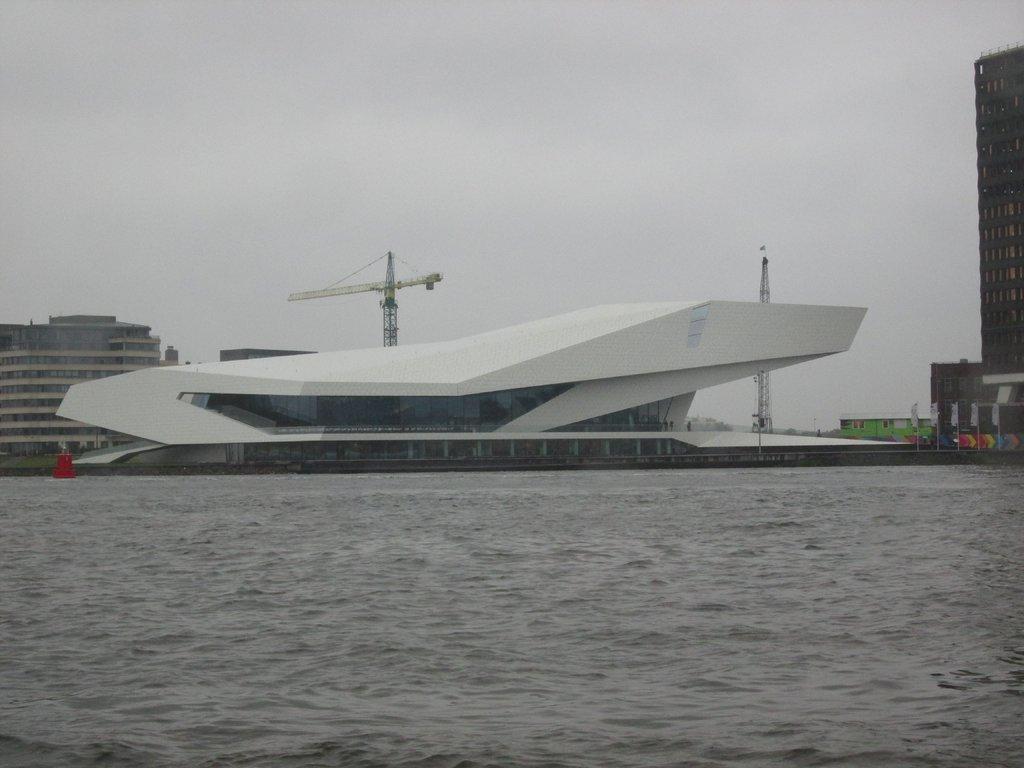Can you describe this image briefly? In this image we can see the buildings and also cranes and flags. In the background there is a cloudy sky and at the bottom we can see the water. 